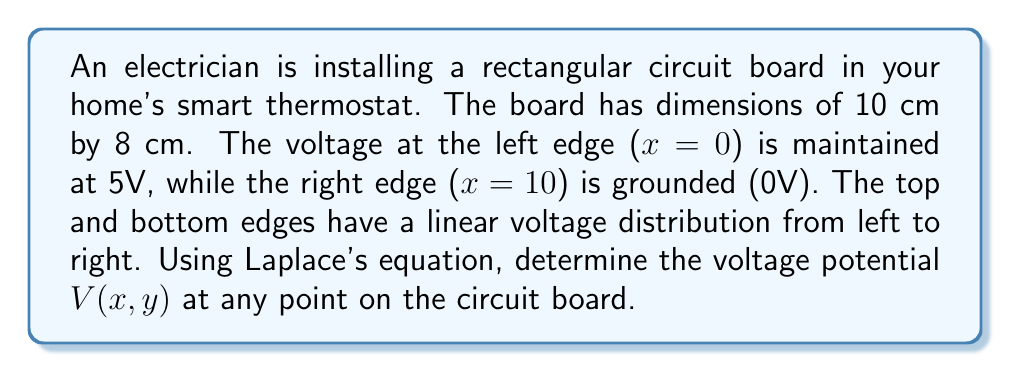Help me with this question. To solve this problem, we'll use Laplace's equation in two dimensions:

$$\frac{\partial^2 V}{\partial x^2} + \frac{\partial^2 V}{\partial y^2} = 0$$

Given the boundary conditions:

1. $V(0,y) = 5$ (left edge)
2. $V(10,y) = 0$ (right edge)
3. $V(x,0) = 5 - \frac{1}{2}x$ (bottom edge)
4. $V(x,8) = 5 - \frac{1}{2}x$ (top edge)

We can use the method of separation of variables. Let $V(x,y) = X(x)Y(y)$.

Substituting into Laplace's equation:

$$X''(x)Y(y) + X(x)Y''(y) = 0$$
$$\frac{X''(x)}{X(x)} = -\frac{Y''(y)}{Y(y)} = -k^2$$

This gives us two ordinary differential equations:

$$X''(x) + k^2X(x) = 0$$
$$Y''(y) - k^2Y(y) = 0$$

The general solutions are:

$$X(x) = A \cos(kx) + B \sin(kx)$$
$$Y(y) = C e^{ky} + D e^{-ky}$$

Applying the boundary conditions for $x$:

$$X(0) = A = 5$$
$$X(10) = 5 \cos(10k) + B \sin(10k) = 0$$

This gives us:

$$B = -5 \cot(10k)$$

The solution that satisfies all boundary conditions is:

$$V(x,y) = 5 - \frac{1}{2}x + \sum_{n=1}^{\infty} A_n \sin(\frac{n\pi x}{10}) \sinh(\frac{n\pi y}{10})$$

Where:

$$A_n = \frac{20}{n\pi \sinh(4n\pi)} \left(1 - (-1)^n\right)$$

This solution satisfies Laplace's equation and all the boundary conditions.
Answer: The voltage potential at any point (x,y) on the circuit board is given by:

$$V(x,y) = 5 - \frac{1}{2}x + \sum_{n=1}^{\infty} \frac{20}{n\pi \sinh(4n\pi)} \left(1 - (-1)^n\right) \sin(\frac{n\pi x}{10}) \sinh(\frac{n\pi y}{10})$$ 